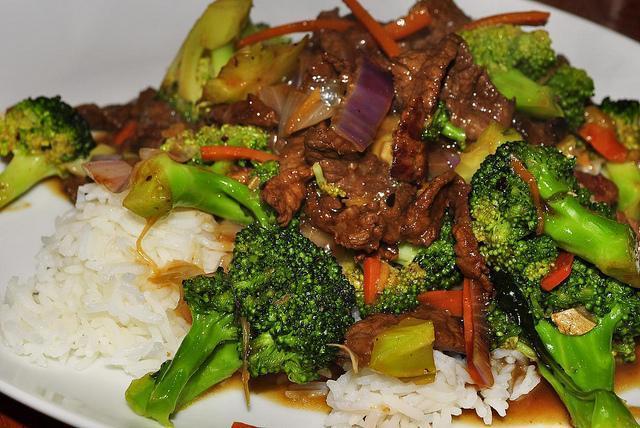How many broccolis can you see?
Give a very brief answer. 8. 